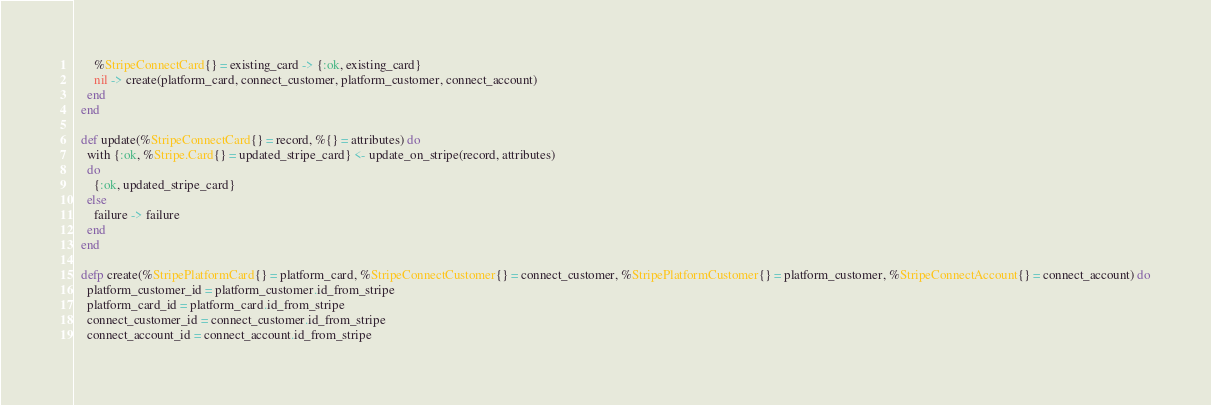Convert code to text. <code><loc_0><loc_0><loc_500><loc_500><_Elixir_>      %StripeConnectCard{} = existing_card -> {:ok, existing_card}
      nil -> create(platform_card, connect_customer, platform_customer, connect_account)
    end
  end

  def update(%StripeConnectCard{} = record, %{} = attributes) do
    with {:ok, %Stripe.Card{} = updated_stripe_card} <- update_on_stripe(record, attributes)
    do
      {:ok, updated_stripe_card}
    else
      failure -> failure
    end
  end

  defp create(%StripePlatformCard{} = platform_card, %StripeConnectCustomer{} = connect_customer, %StripePlatformCustomer{} = platform_customer, %StripeConnectAccount{} = connect_account) do
    platform_customer_id = platform_customer.id_from_stripe
    platform_card_id = platform_card.id_from_stripe
    connect_customer_id = connect_customer.id_from_stripe
    connect_account_id = connect_account.id_from_stripe
</code> 